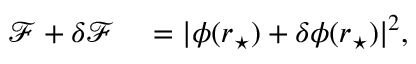<formula> <loc_0><loc_0><loc_500><loc_500>\begin{array} { r l } { \mathcal { F } + \delta \mathcal { F } } & = | \phi ( r _ { ^ { * } } ) + \delta \phi ( r _ { ^ { * } } ) | ^ { 2 } , } \end{array}</formula> 